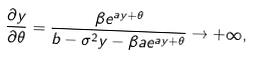<formula> <loc_0><loc_0><loc_500><loc_500>\frac { \partial y } { \partial \theta } = \frac { \beta e ^ { a y + \theta } } { b - \sigma ^ { 2 } y - \beta a e ^ { a y + \theta } } \rightarrow + \infty ,</formula> 